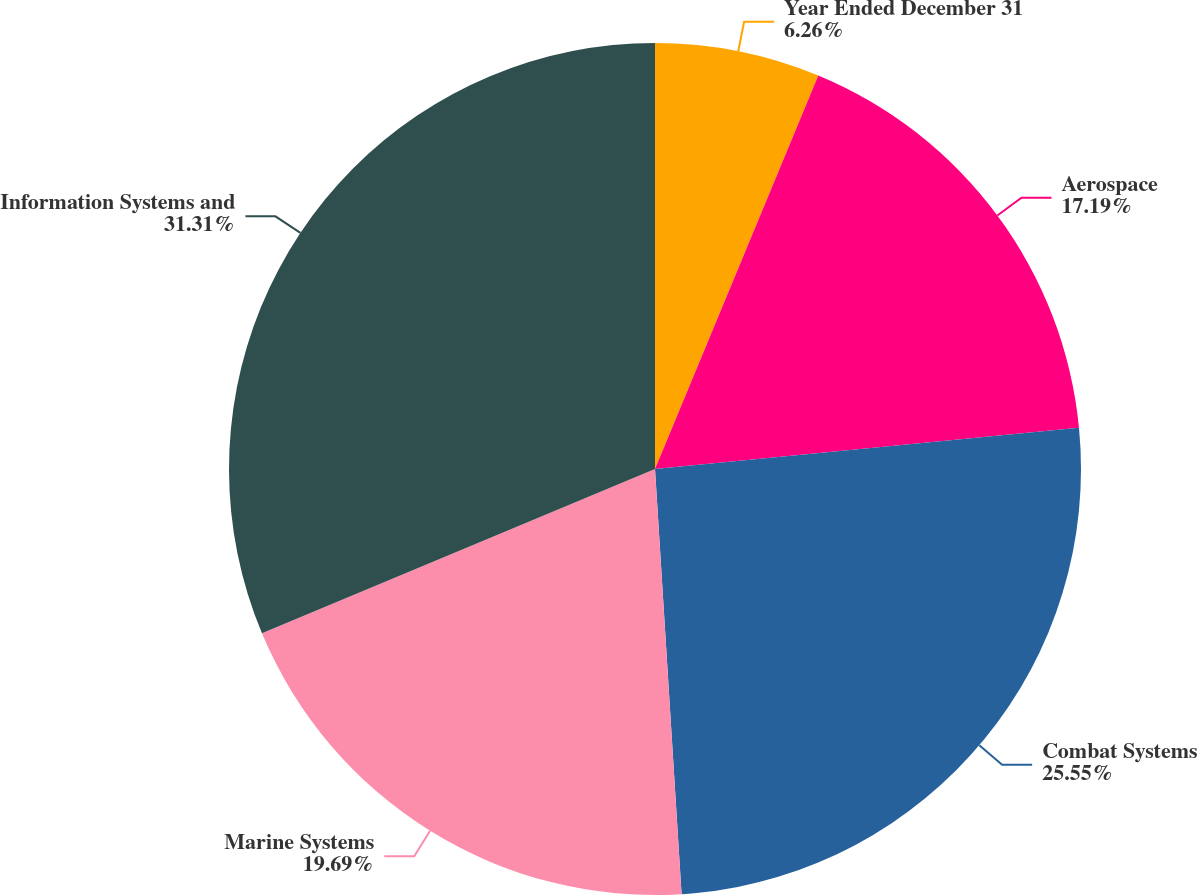<chart> <loc_0><loc_0><loc_500><loc_500><pie_chart><fcel>Year Ended December 31<fcel>Aerospace<fcel>Combat Systems<fcel>Marine Systems<fcel>Information Systems and<nl><fcel>6.26%<fcel>17.19%<fcel>25.55%<fcel>19.69%<fcel>31.3%<nl></chart> 